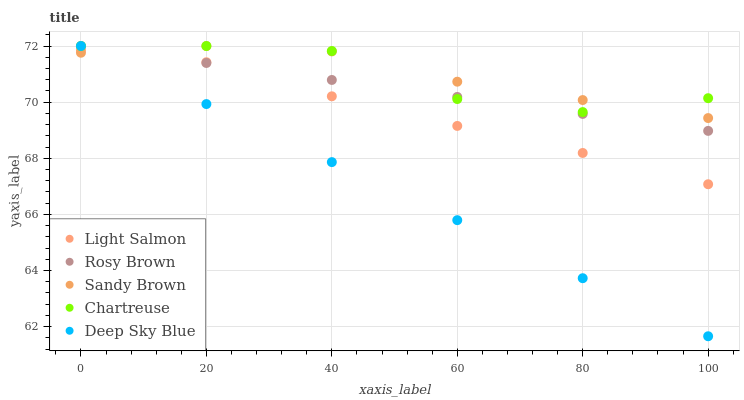Does Deep Sky Blue have the minimum area under the curve?
Answer yes or no. Yes. Does Sandy Brown have the maximum area under the curve?
Answer yes or no. Yes. Does Rosy Brown have the minimum area under the curve?
Answer yes or no. No. Does Rosy Brown have the maximum area under the curve?
Answer yes or no. No. Is Deep Sky Blue the smoothest?
Answer yes or no. Yes. Is Chartreuse the roughest?
Answer yes or no. Yes. Is Rosy Brown the smoothest?
Answer yes or no. No. Is Rosy Brown the roughest?
Answer yes or no. No. Does Deep Sky Blue have the lowest value?
Answer yes or no. Yes. Does Rosy Brown have the lowest value?
Answer yes or no. No. Does Deep Sky Blue have the highest value?
Answer yes or no. Yes. Is Light Salmon less than Chartreuse?
Answer yes or no. Yes. Is Chartreuse greater than Light Salmon?
Answer yes or no. Yes. Does Deep Sky Blue intersect Sandy Brown?
Answer yes or no. Yes. Is Deep Sky Blue less than Sandy Brown?
Answer yes or no. No. Is Deep Sky Blue greater than Sandy Brown?
Answer yes or no. No. Does Light Salmon intersect Chartreuse?
Answer yes or no. No. 